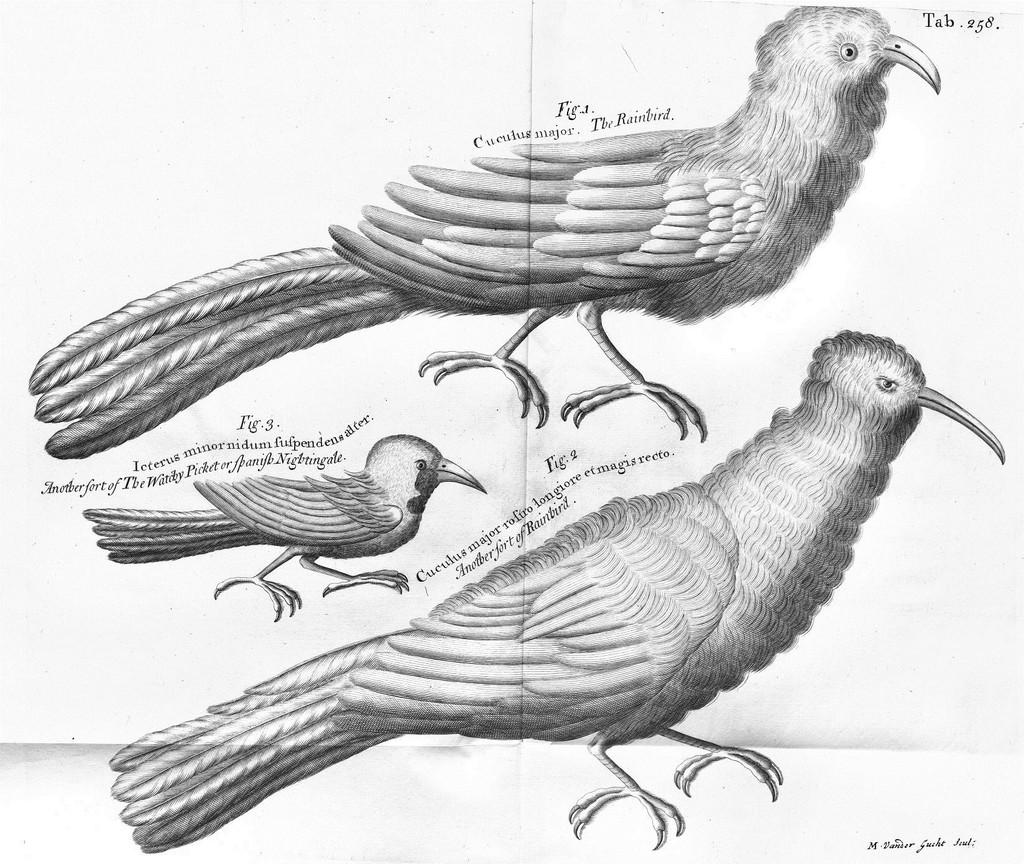What is depicted in the drawing in the image? There is a drawing of birds in the image. How are the birds in the drawing identified or organized? The birds in the drawing are labeled with numbers. What else can be seen in the image besides the drawing of birds? There is writing on a white surface in the image. What type of coil is used to create the birds' tails in the drawing? There is no coil present in the drawing; the birds' tails are depicted using lines and shapes. What is the plot of the story being told through the writing on the white surface? There is no story being told through the writing on the white surface in the image; it is simply text on a surface. 